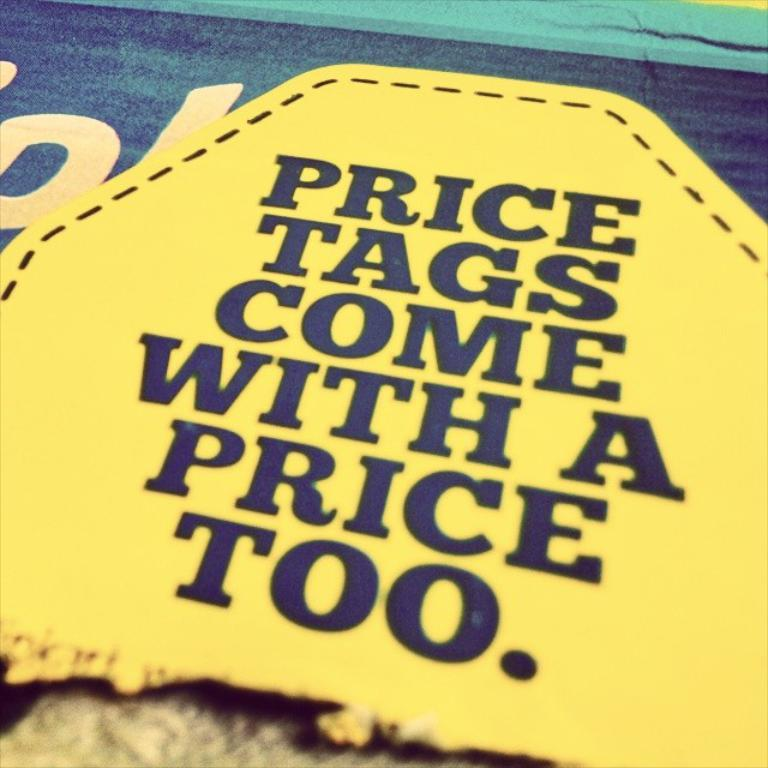<image>
Provide a brief description of the given image. A yellow sign with slogan price tags comes with a price too. 